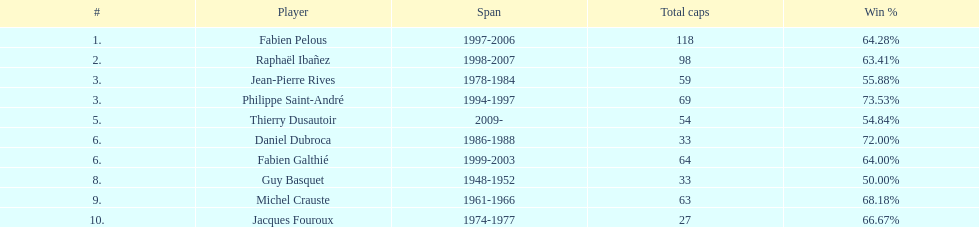How long did michel crauste serve as captain? 1961-1966. Could you parse the entire table as a dict? {'header': ['#', 'Player', 'Span', 'Total caps', 'Win\xa0%'], 'rows': [['1.', 'Fabien Pelous', '1997-2006', '118', '64.28%'], ['2.', 'Raphaël Ibañez', '1998-2007', '98', '63.41%'], ['3.', 'Jean-Pierre Rives', '1978-1984', '59', '55.88%'], ['3.', 'Philippe Saint-André', '1994-1997', '69', '73.53%'], ['5.', 'Thierry Dusautoir', '2009-', '54', '54.84%'], ['6.', 'Daniel Dubroca', '1986-1988', '33', '72.00%'], ['6.', 'Fabien Galthié', '1999-2003', '64', '64.00%'], ['8.', 'Guy Basquet', '1948-1952', '33', '50.00%'], ['9.', 'Michel Crauste', '1961-1966', '63', '68.18%'], ['10.', 'Jacques Fouroux', '1974-1977', '27', '66.67%']]} 